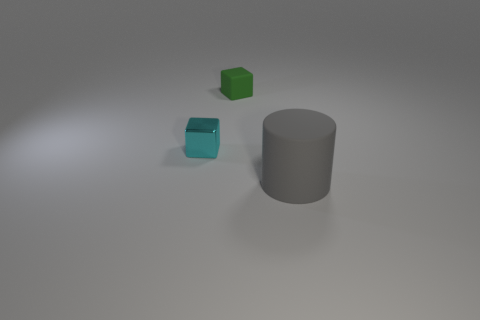Is there any other thing that is the same size as the gray cylinder?
Provide a succinct answer. No. What number of matte objects are gray objects or purple cylinders?
Provide a short and direct response. 1. The green object has what shape?
Offer a terse response. Cube. There is a green object that is the same size as the cyan block; what material is it?
Provide a succinct answer. Rubber. What number of small objects are either spheres or rubber blocks?
Offer a terse response. 1. Is there a large matte thing?
Make the answer very short. Yes. There is a green block that is made of the same material as the large object; what size is it?
Provide a succinct answer. Small. Does the tiny green block have the same material as the cyan object?
Make the answer very short. No. How many other objects are the same material as the tiny green object?
Offer a very short reply. 1. What number of objects are right of the tiny cyan metal object and to the left of the matte cylinder?
Provide a succinct answer. 1. 